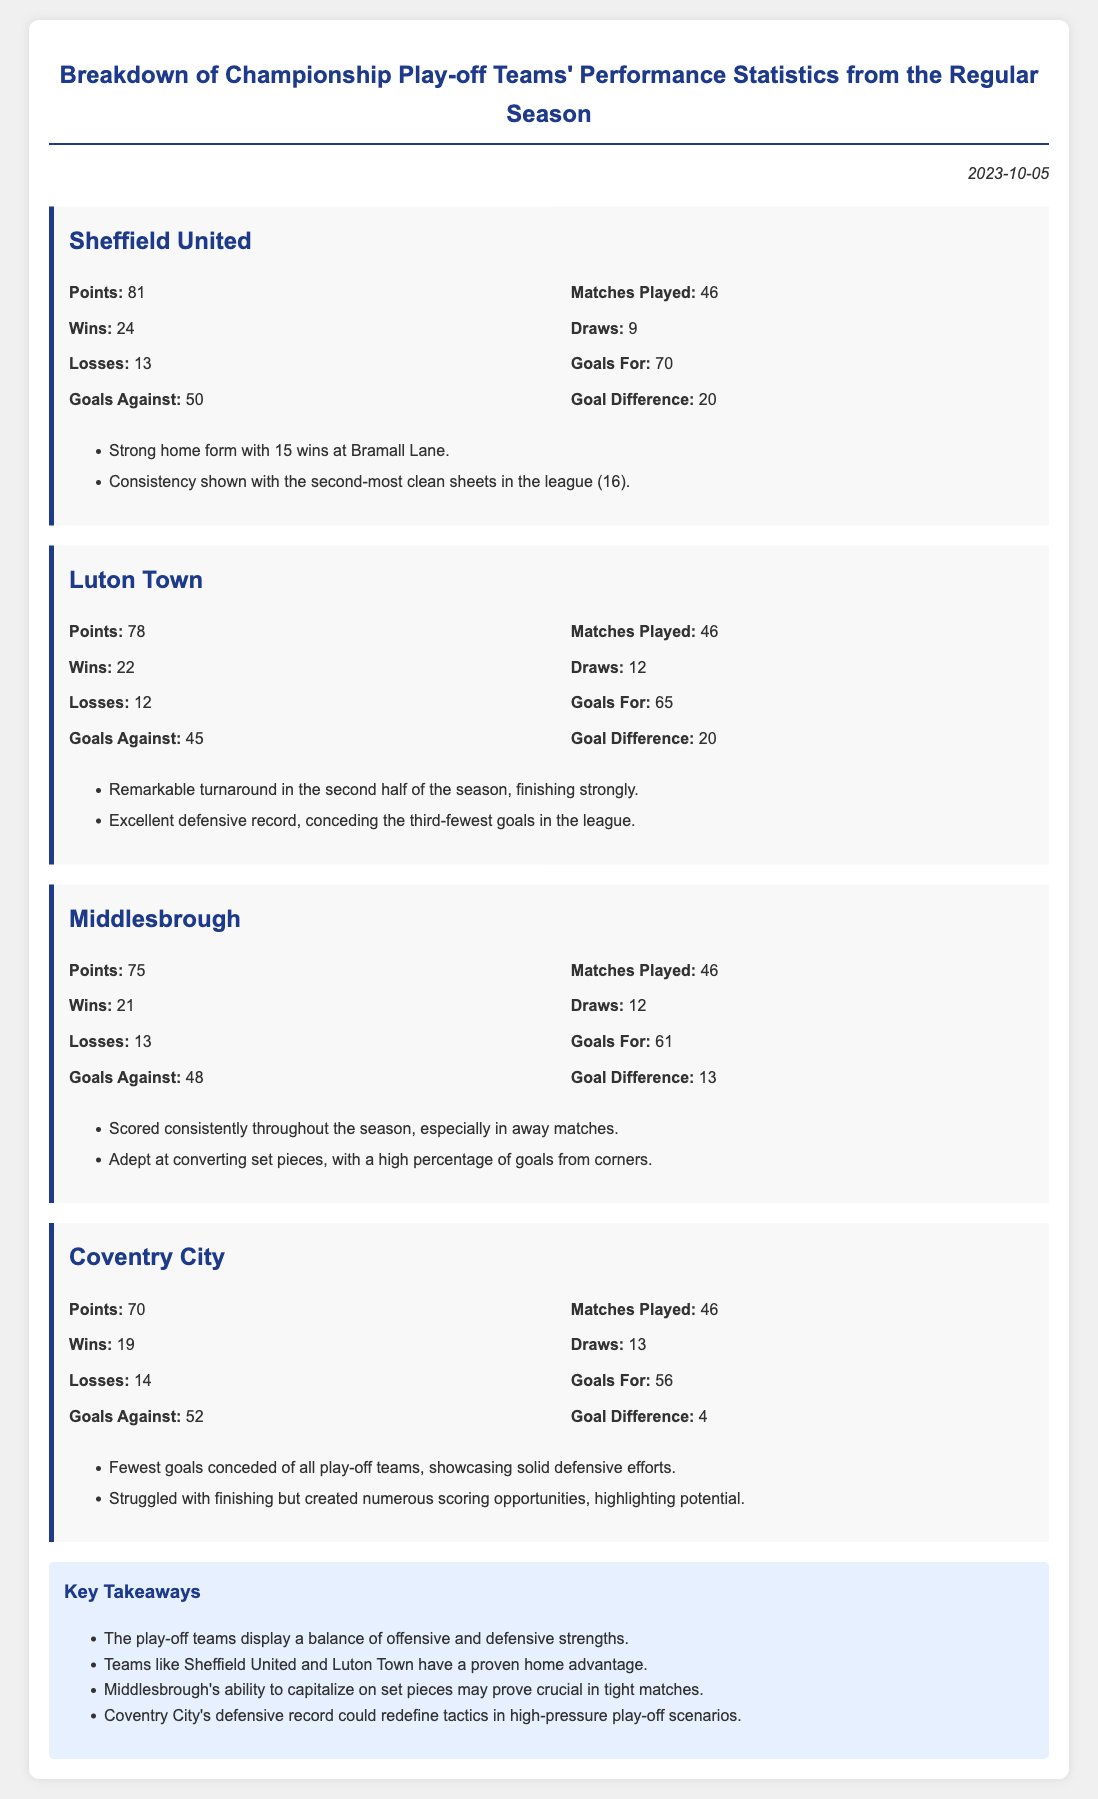What is the total number of points for Sheffield United? The total points for Sheffield United are listed as 81 in their performance statistics.
Answer: 81 How many matches did Coventry City play? Coventry City played a total of 46 matches, as stated in their performance section.
Answer: 46 Which team has the highest number of wins? Sheffield United has the highest number of wins, with 24 listed in their metrics.
Answer: 24 What was the goal difference for Luton Town? The goal difference for Luton Town is specified as 20 in their performance statistics.
Answer: 20 Which team had the fewest goals conceded? Coventry City had the fewest goals conceded among the play-off teams, with a statistic indicating this fact.
Answer: Fewest goals conceded What was a notable strength of Middlesbrough? Middlesbrough is noted for being adept at converting set pieces, highlighting their tactical strength.
Answer: Set pieces What is the date of the memo? The date of the memo can be found in the header, indicating it was published on October 5, 2023.
Answer: 2023-10-05 Which team scored the most goals? Sheffield United scored the most goals in the regular season with 70, as mentioned in their statistics.
Answer: 70 What is a shared characteristic of the play-off teams? The play-off teams exhibit a balance of offensive and defensive strengths, as summarized in the key takeaways.
Answer: Balance of strengths 